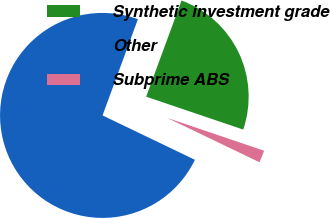<chart> <loc_0><loc_0><loc_500><loc_500><pie_chart><fcel>Synthetic investment grade<fcel>Other<fcel>Subprime ABS<nl><fcel>24.59%<fcel>73.48%<fcel>1.93%<nl></chart> 